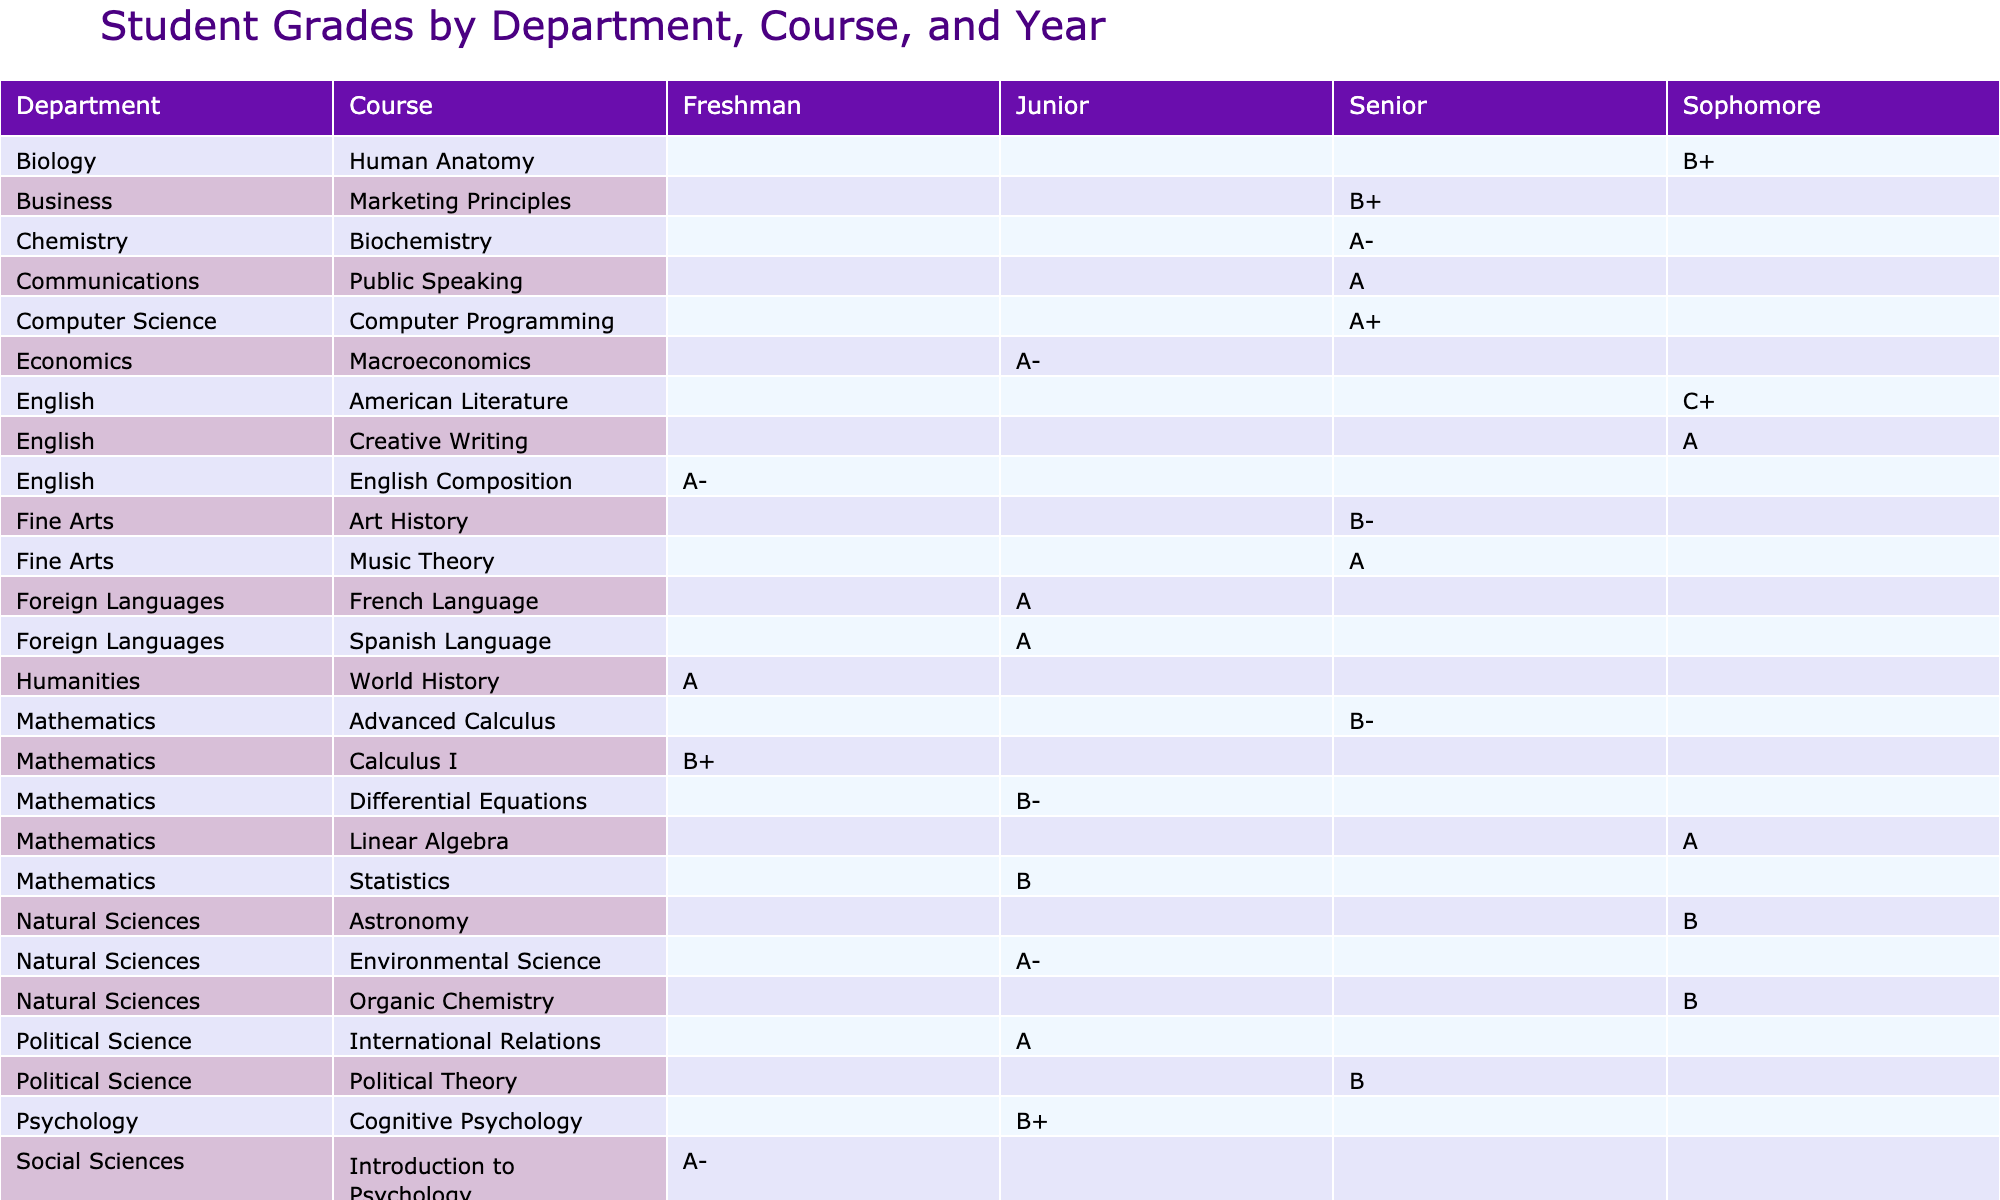What are the grades for Organic Chemistry in the sophomore year? The table indicates that Michael Chen achieved a grade of B in Organic Chemistry, which is listed under the Natural Sciences department for the sophomore year.
Answer: B Which course has the highest attendance percentage among all students? By examining the attendance percentages across courses, Computer Programming has the highest attendance at 97%.
Answer: 97 What is the average attendance percentage for courses in the Social Sciences department? The attendance percentages for the Social Sciences department are 92 (Sociology) and 89 (Microeconomics), giving a sum of 181. Dividing by the 2 courses, 181/2 = 90.5.
Answer: 90.5 Did Emma Wilson achieve A grades in more than one course during her senior year? Looking at Emma Wilson's grades for senior year, she achieved an A in Music Theory and an A- in Biochemistry, making it two courses with A grades.
Answer: Yes Which student has the lowest average grade across all their courses for the semester? First, we calculate the numerical equivalence of the grades: Michael Chen: (3.0 for C+ + 3.3 for B + 3.7 for B+ + 3.67 for A) / 4 = 3.245; comparing this with other students, Michael has the lowest average.
Answer: Michael Chen 